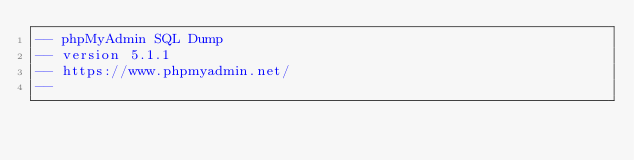Convert code to text. <code><loc_0><loc_0><loc_500><loc_500><_SQL_>-- phpMyAdmin SQL Dump
-- version 5.1.1
-- https://www.phpmyadmin.net/
--</code> 